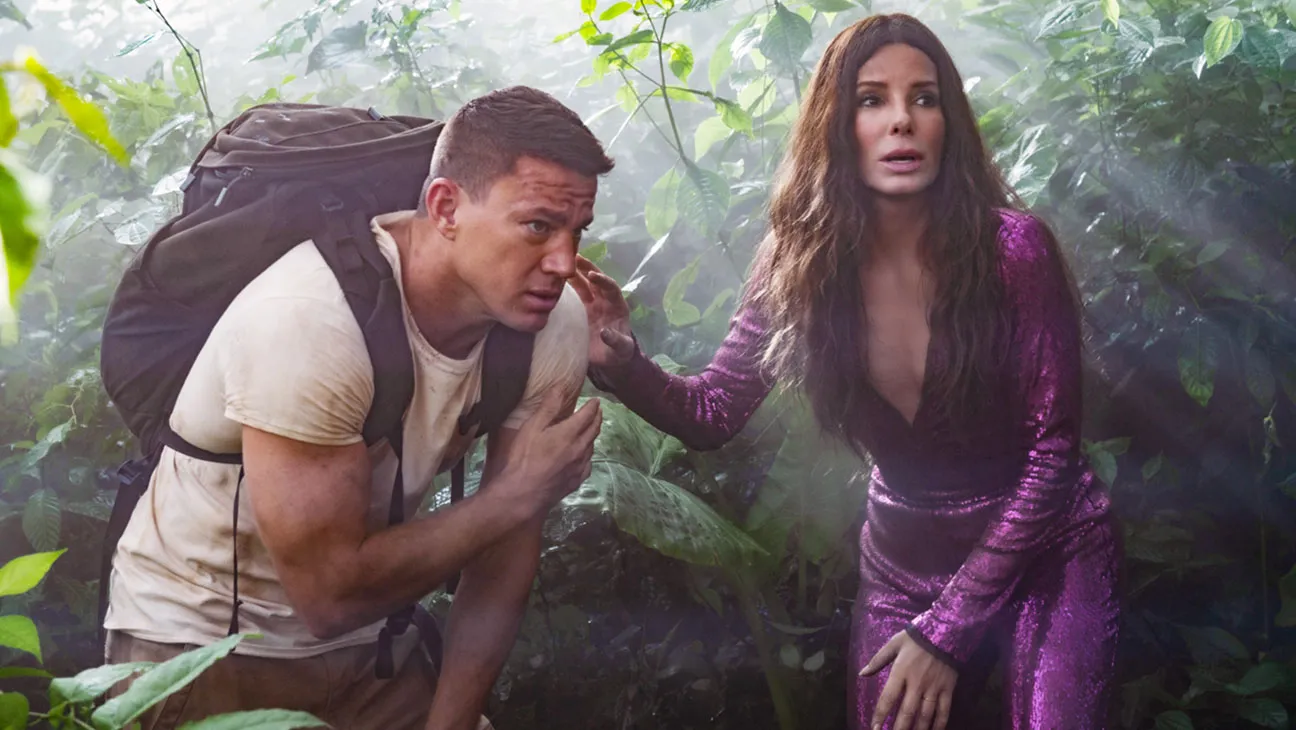What could have caused the sense of apprehension shown on the actors' faces in this scene? The actors' expressions of apprehension could be due to an imminent danger or a critical situation they are facing in their adventure. It might be a sudden encounter with wildlife, a natural hazard, or they could be lost. The dense setting amplifies the sense of uncertainty and urgency in their mission. 